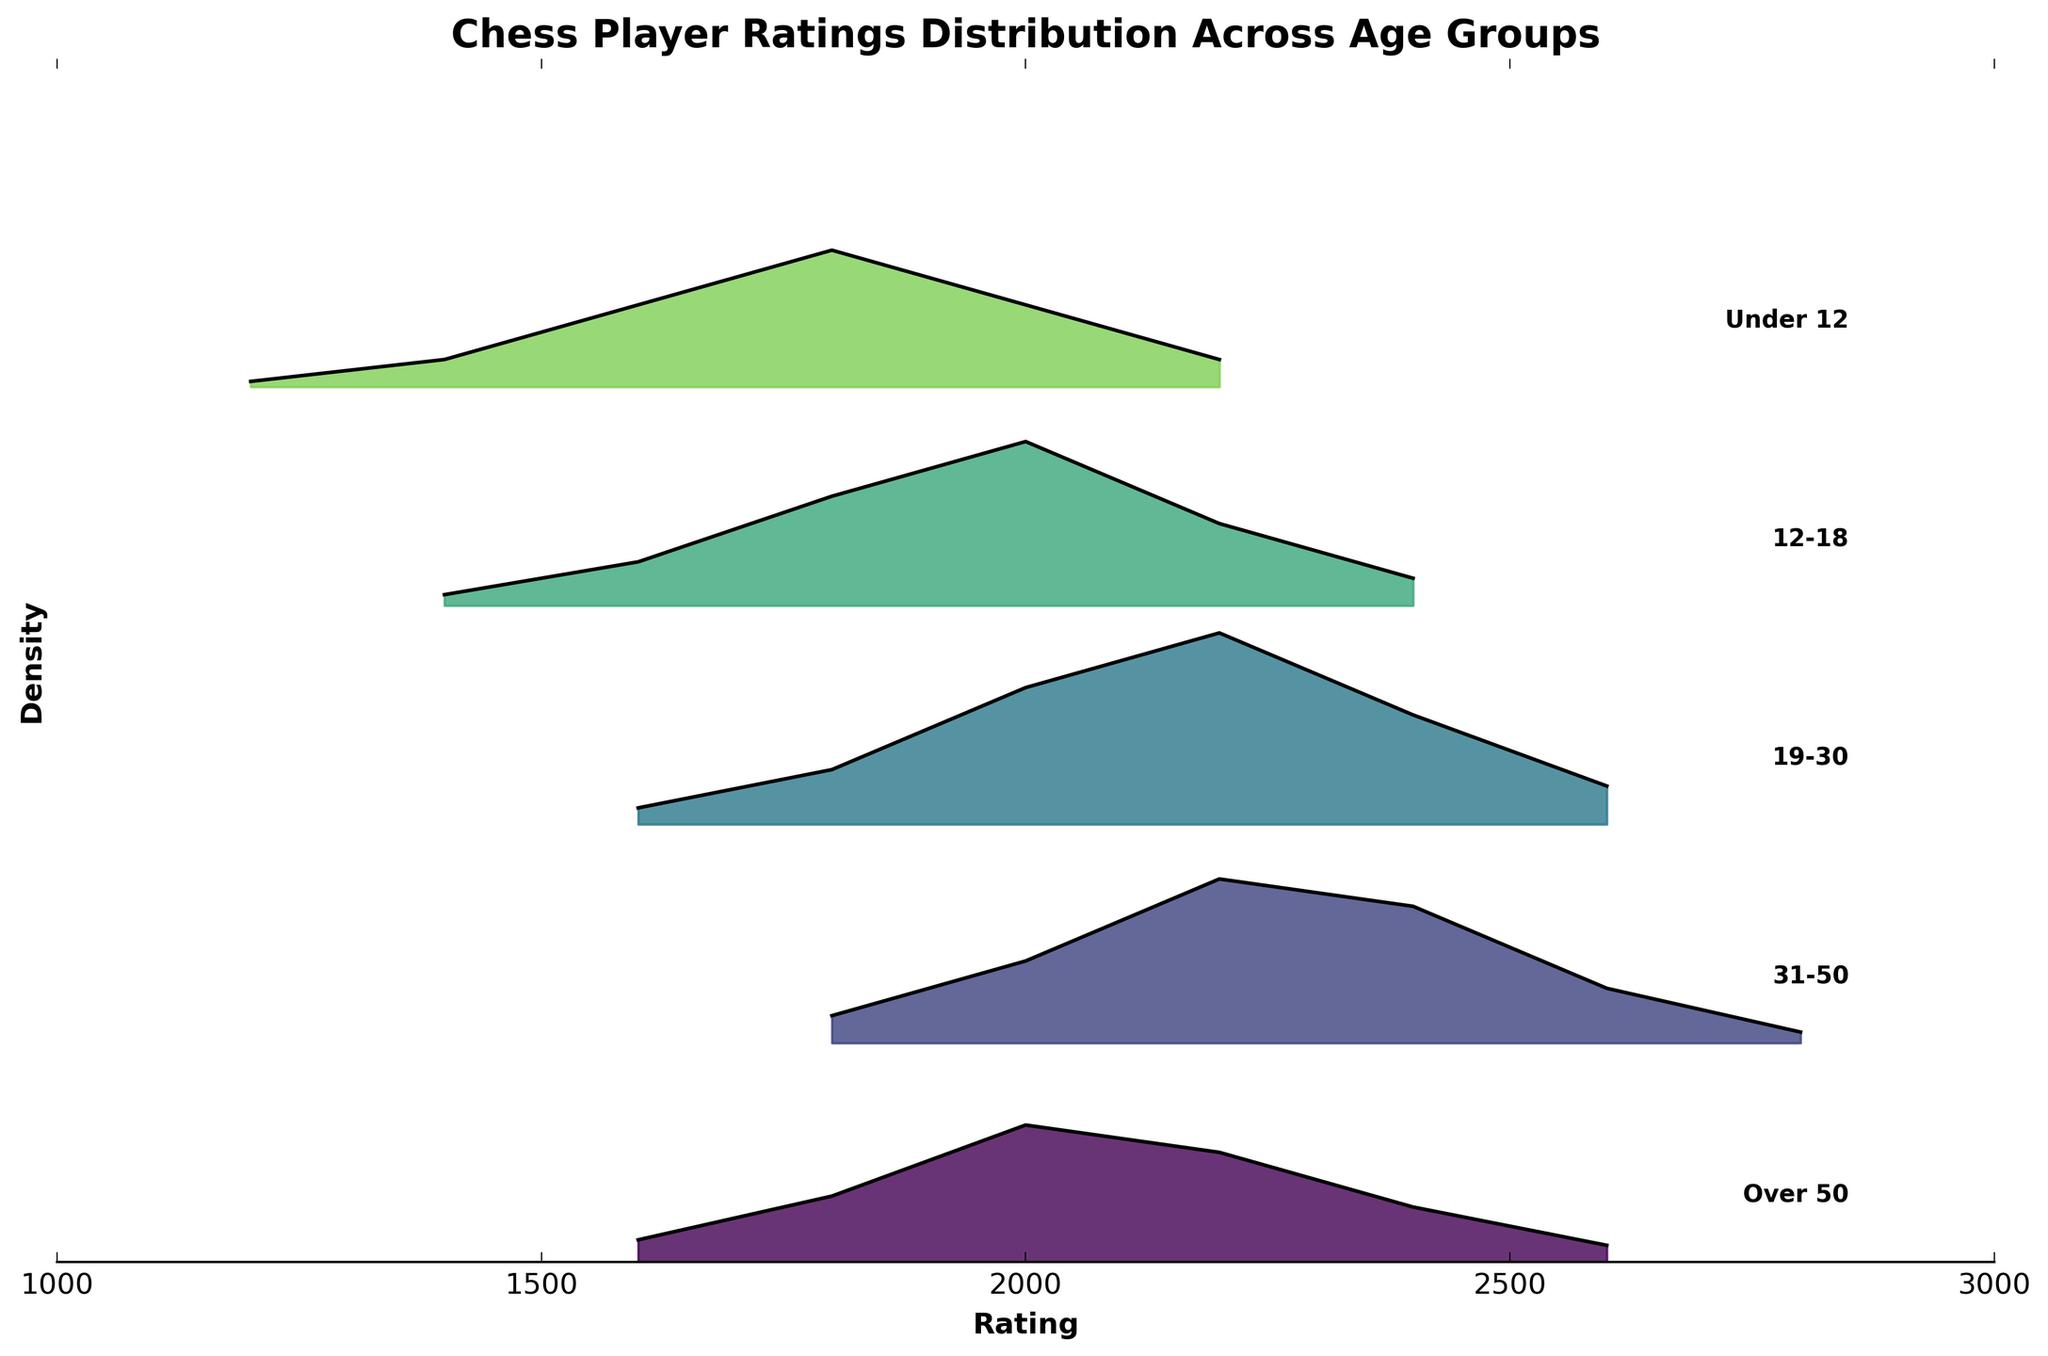What is the title of the figure? The title of the figure is clearly labeled at the top.
Answer: Chess Player Ratings Distribution Across Age Groups Which age group has the highest density for player ratings of 2000? By observing the peak density for the rating 2000 on the x-axis, the 19-30 age group shows the highest density.
Answer: 19-30 How does the density of the “Under 12” age group for player ratings compare from 1800 to 2200? For ratings 1800 to 2200, the density starts at 0.025 at 1800, decreases to 0.015 at 2000, and further decreases to 0.005 at 2200 for the "Under 12" group.
Answer: Decreasing Which age group shows a player rating density peaking at 2400? Observing the x-axis at the rating of 2400, the age group with a visible density peak is 31-50.
Answer: 31-50 What is the trend of player rating densities as age increases? The densities generally peak at higher ratings as the age groups progress from Under 12 to Over 50, indicating higher ratings are more common in older age groups.
Answer: Higher peaks at higher ratings with age What is the rating range displayed on the x-axis? The x-axis displays ratings ranging from 1000 to 3000. This can be seen from the x-axis markings and limits.
Answer: 1000 to 3000 For which age group is the density consistently the lowest across all ratings? By comparing the densities across all age groups, the "Over 50" group generally shows the lowest densities.
Answer: Over 50 How many distinct age groups are represented in the plot? The age groups listed on the right side of the plot include Under 12, 12-18, 19-30, 31-50, and Over 50, totaling five groups.
Answer: 5 Which age group demonstrates the widest spread in rating density? The 19-30 age group shows density spread across a wide range of ratings from 1600 to 2600.
Answer: 19-30 Do older age groups demonstrate higher maximum densities than younger age groups? The maximum densities appear higher for older age groups, particularly 19-30 and 31-50 age groups, compared to younger groups like Under 12.
Answer: Yes 